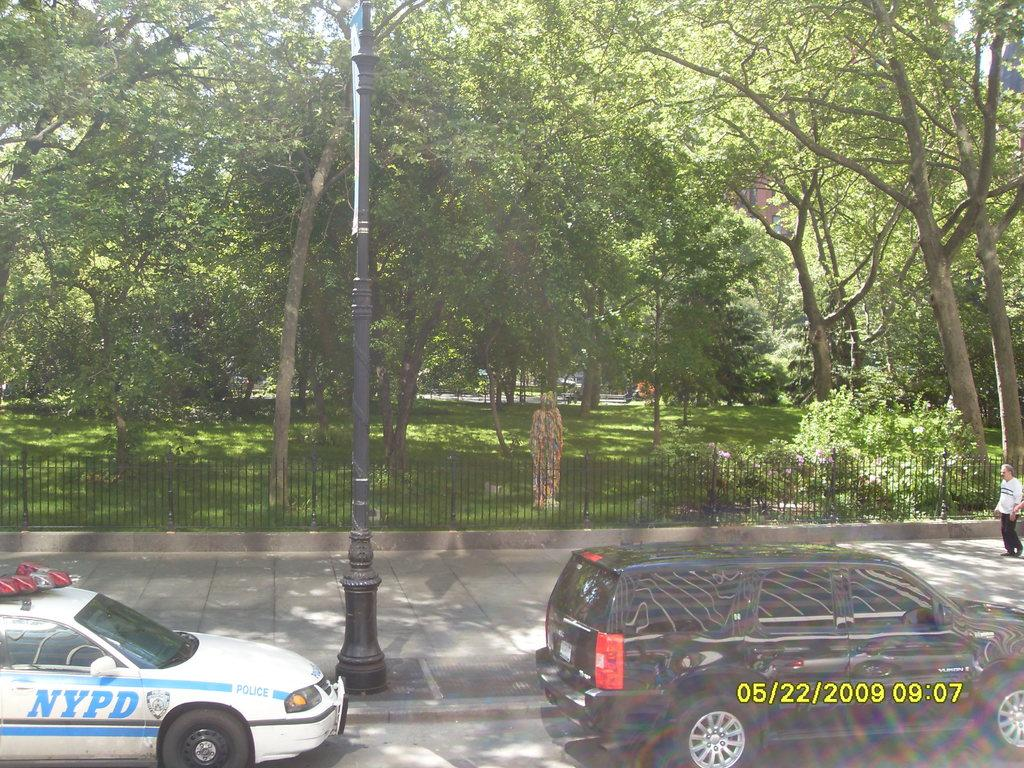What can be seen at the top of the image? The sky is visible at the top of the image. What type of structures are present in the image? There are buildings in the image. What type of vegetation is present in the image? Trees are present in the image. What type of urban infrastructure can be seen in the image? A street pole is visible in the image. What type of barrier is present in the image? An iron grill is present in the image. What type of artwork is present in the image? There is a statue in the image. What type of surface is visible in the image? The ground is visible in the image. What type of transportation is present in the image? Motor vehicles are present in the image. Is there a person visible in the image? Yes, a person (presumably "pearson") is in the image. What type of pathway is present in the image? There is a road in the image. How many rabbits are hopping around the statue in the image? There are no rabbits present in the image; only the statue is visible. What type of tent is set up near the road in the image? There is no tent present in the image; only the road and other elements are visible. 